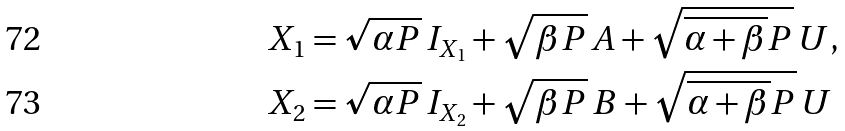Convert formula to latex. <formula><loc_0><loc_0><loc_500><loc_500>X _ { 1 } & = \sqrt { \alpha P } \, I _ { X _ { 1 } } + \sqrt { \beta P } \, A + \sqrt { \overline { \alpha + \beta } P } \, U , \\ X _ { 2 } & = \sqrt { \alpha P } \, I _ { X _ { 2 } } + \sqrt { \beta P } \, B + \sqrt { \overline { \alpha + \beta } P } \, U</formula> 